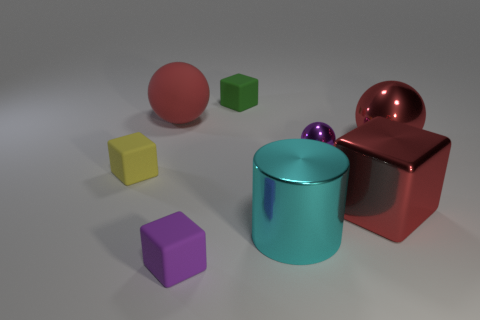Is the number of small shiny objects that are in front of the yellow object the same as the number of blue metallic things?
Provide a succinct answer. Yes. What shape is the small green matte thing?
Provide a succinct answer. Cube. Is there anything else that has the same color as the shiny cylinder?
Offer a very short reply. No. There is a red shiny thing that is behind the tiny yellow rubber thing; does it have the same size as the rubber block behind the purple sphere?
Offer a terse response. No. There is a purple thing right of the purple object that is in front of the cylinder; what is its shape?
Provide a succinct answer. Sphere. Do the purple cube and the cube behind the big red shiny sphere have the same size?
Your answer should be very brief. Yes. There is a red thing behind the red sphere that is right of the red metal object in front of the purple metal object; how big is it?
Ensure brevity in your answer.  Large. What number of objects are things on the right side of the small green block or blue spheres?
Offer a terse response. 4. What number of large red matte spheres are in front of the small thing that is on the left side of the large red rubber ball?
Keep it short and to the point. 0. Is the number of purple balls to the left of the big red matte thing greater than the number of yellow things?
Make the answer very short. No. 